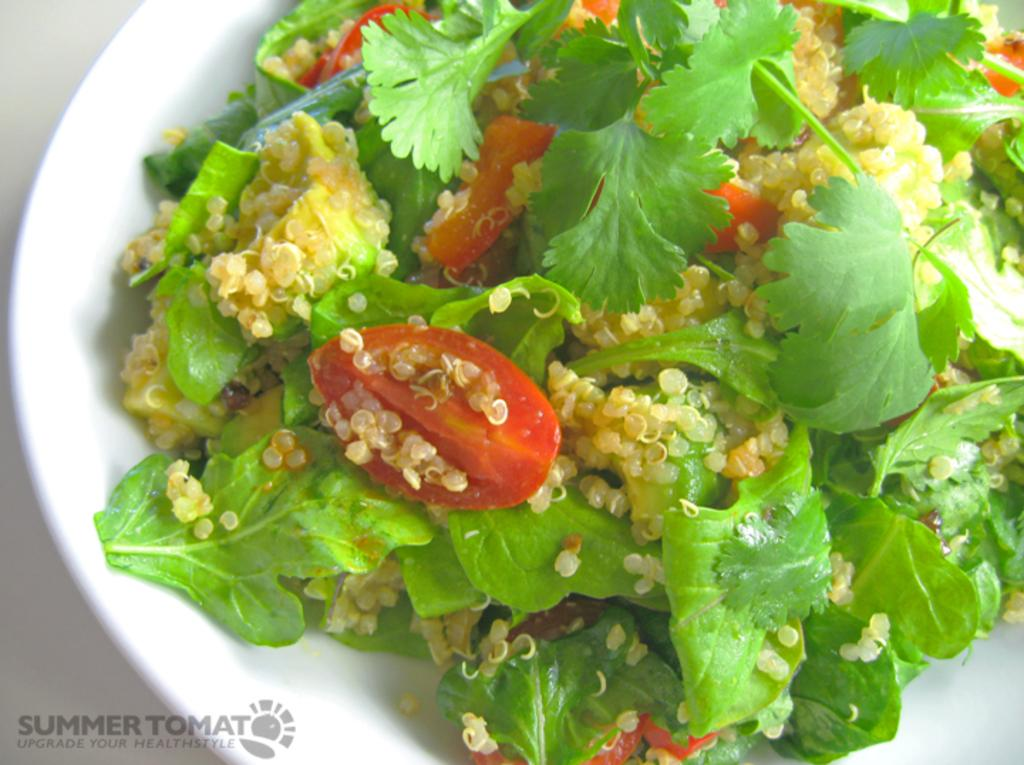What is present on the plate in the image? There is food in a plate in the image. Can you describe anything else that might be present in the image? Yes, there is a watermark in the bottom left-hand side of the image. How many volleyball players can be seen playing in the image? There are no volleyball players present in the image. What type of balance is required for the food on the plate in the image? The food on the plate does not require any specific balance, as it is stationary in the image. 